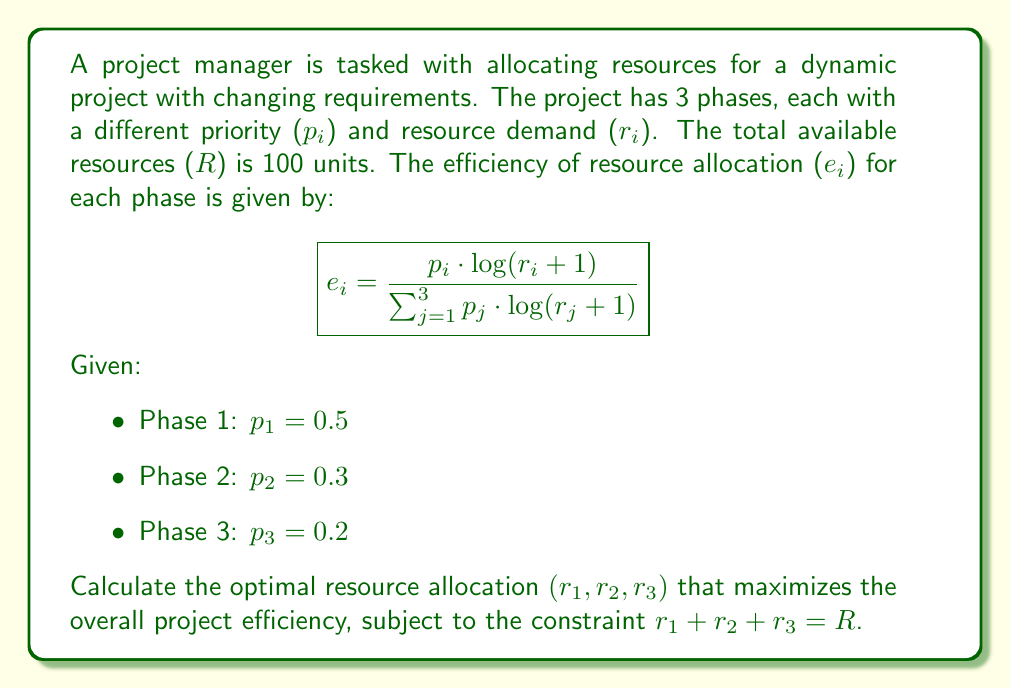What is the answer to this math problem? To solve this problem, we'll use the method of Lagrange multipliers:

1) Define the objective function:
   $$f(r_1, r_2, r_3) = e_1 + e_2 + e_3 = 1$$

2) Define the constraint:
   $$g(r_1, r_2, r_3) = r_1 + r_2 + r_3 - R = 0$$

3) Form the Lagrangian:
   $$L(r_1, r_2, r_3, \lambda) = f(r_1, r_2, r_3) - \lambda g(r_1, r_2, r_3)$$

4) Set partial derivatives to zero:
   $$\frac{\partial L}{\partial r_i} = \frac{p_i}{r_i + 1} - \lambda = 0 \quad \text{for } i = 1, 2, 3$$

5) Solve for $r_i$:
   $$r_i = \frac{p_i}{\lambda} - 1 \quad \text{for } i = 1, 2, 3$$

6) Substitute into the constraint:
   $$\frac{p_1}{\lambda} - 1 + \frac{p_2}{\lambda} - 1 + \frac{p_3}{\lambda} - 1 = R$$
   $$\frac{p_1 + p_2 + p_3}{\lambda} = R + 3$$
   $$\lambda = \frac{p_1 + p_2 + p_3}{R + 3} = \frac{1}{103}$$

7) Calculate optimal resource allocation:
   $$r_1 = \frac{0.5}{1/103} - 1 = 50.5$$
   $$r_2 = \frac{0.3}{1/103} - 1 = 29.9$$
   $$r_3 = \frac{0.2}{1/103} - 1 = 19.6$$

8) Round to nearest integer to maintain the constraint:
   $$r_1 = 51, r_2 = 30, r_3 = 19$$
Answer: $(51, 30, 19)$ 